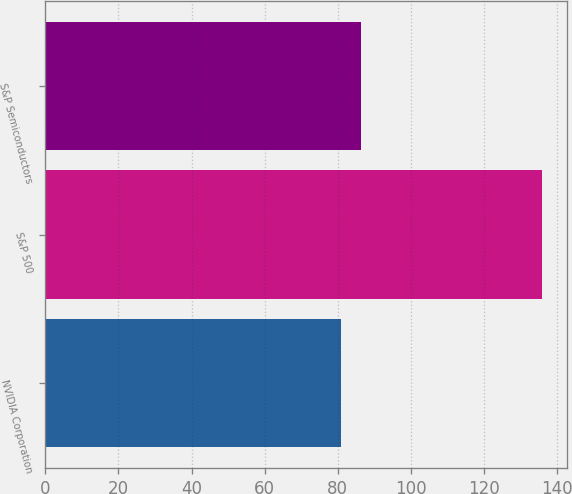Convert chart. <chart><loc_0><loc_0><loc_500><loc_500><bar_chart><fcel>NVIDIA Corporation<fcel>S&P 500<fcel>S&P Semiconductors<nl><fcel>80.98<fcel>135.92<fcel>86.47<nl></chart> 